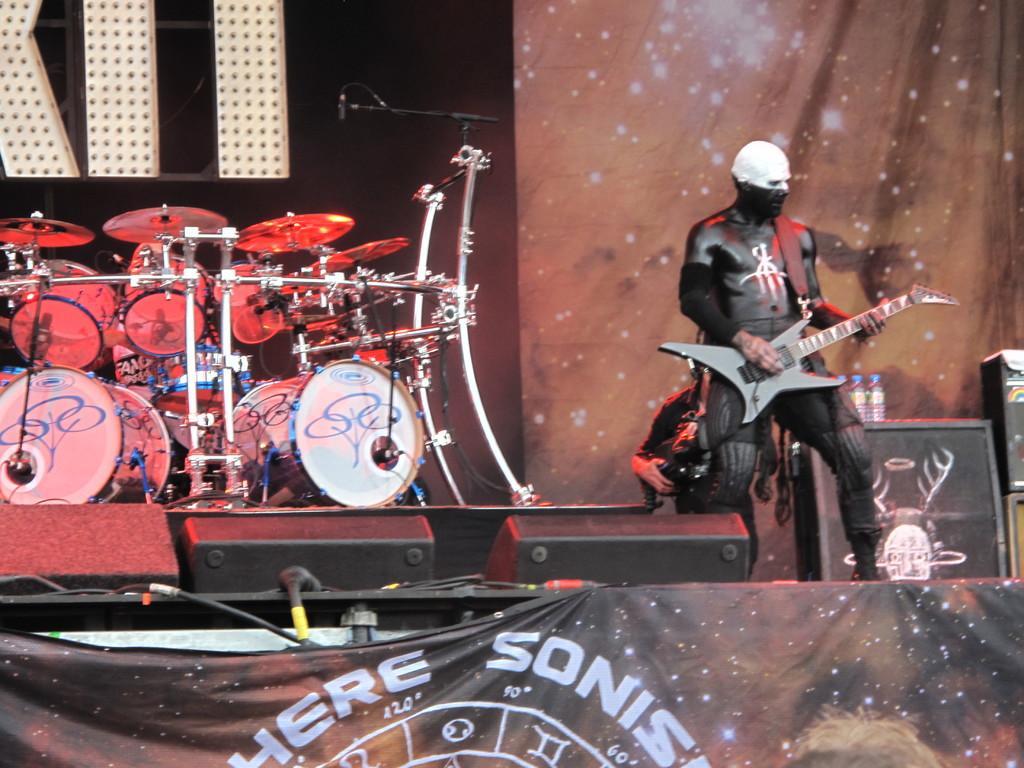Please provide a concise description of this image. This is a stage. On the stage there is a person playing guitar. Also there are drums and speakers. Also there is a wall. There is a mic with mic stands. There are bottles on a box. There is a banner. Also there is a person in the back. 